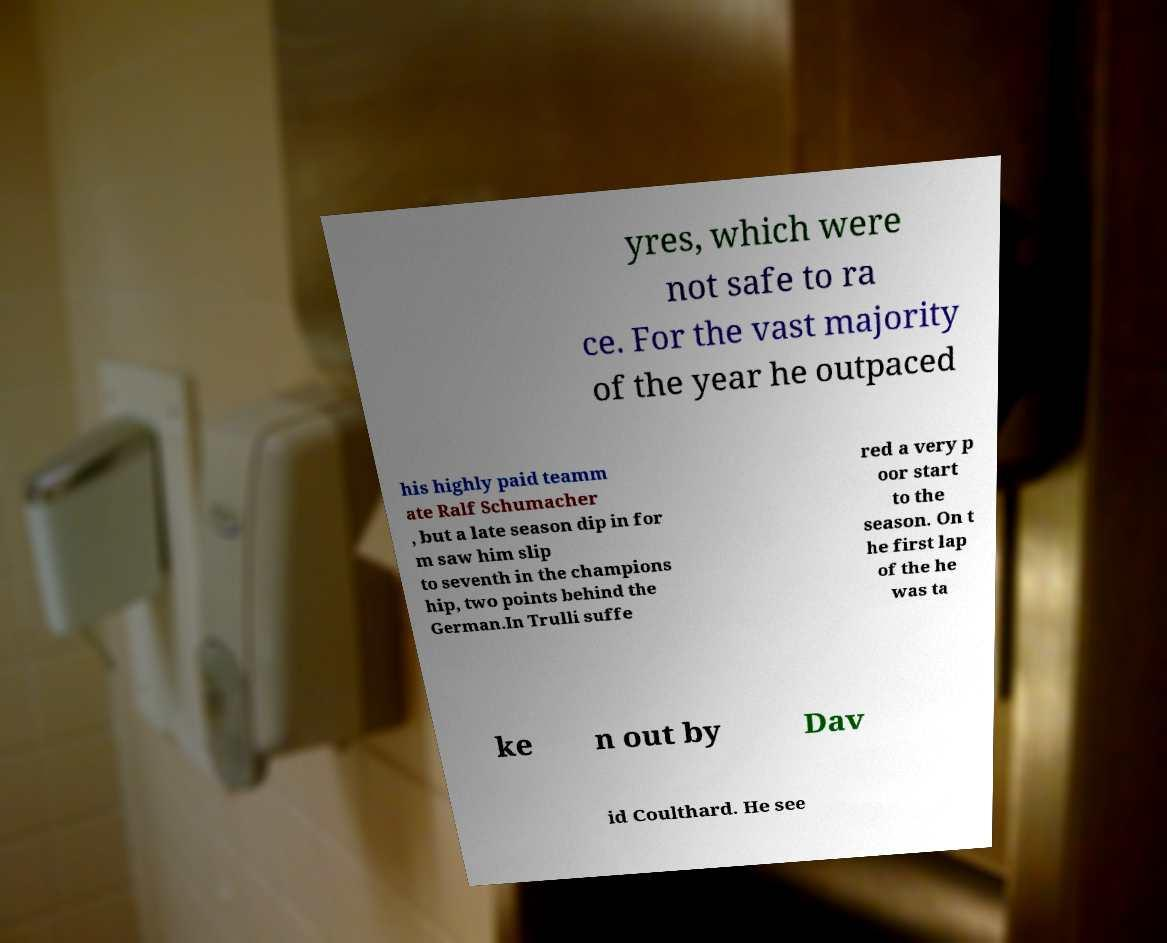Please read and relay the text visible in this image. What does it say? yres, which were not safe to ra ce. For the vast majority of the year he outpaced his highly paid teamm ate Ralf Schumacher , but a late season dip in for m saw him slip to seventh in the champions hip, two points behind the German.In Trulli suffe red a very p oor start to the season. On t he first lap of the he was ta ke n out by Dav id Coulthard. He see 